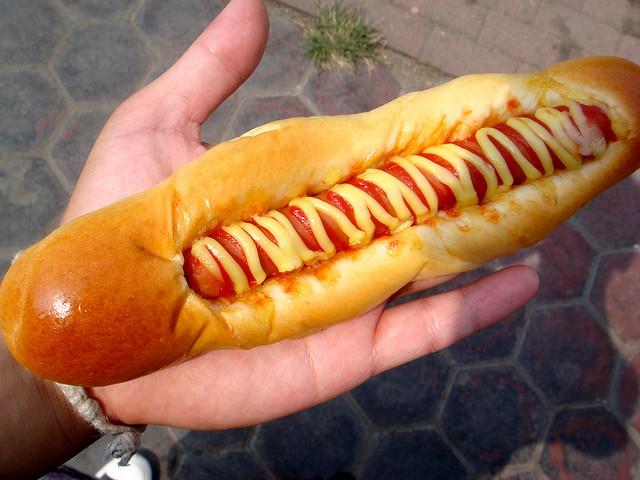What hand is he holding the hot dog with?
Quick response, please. Left. What is on the hotdog?
Write a very short answer. Cheese. Is the bun longer than the hotdog?
Keep it brief. Yes. 